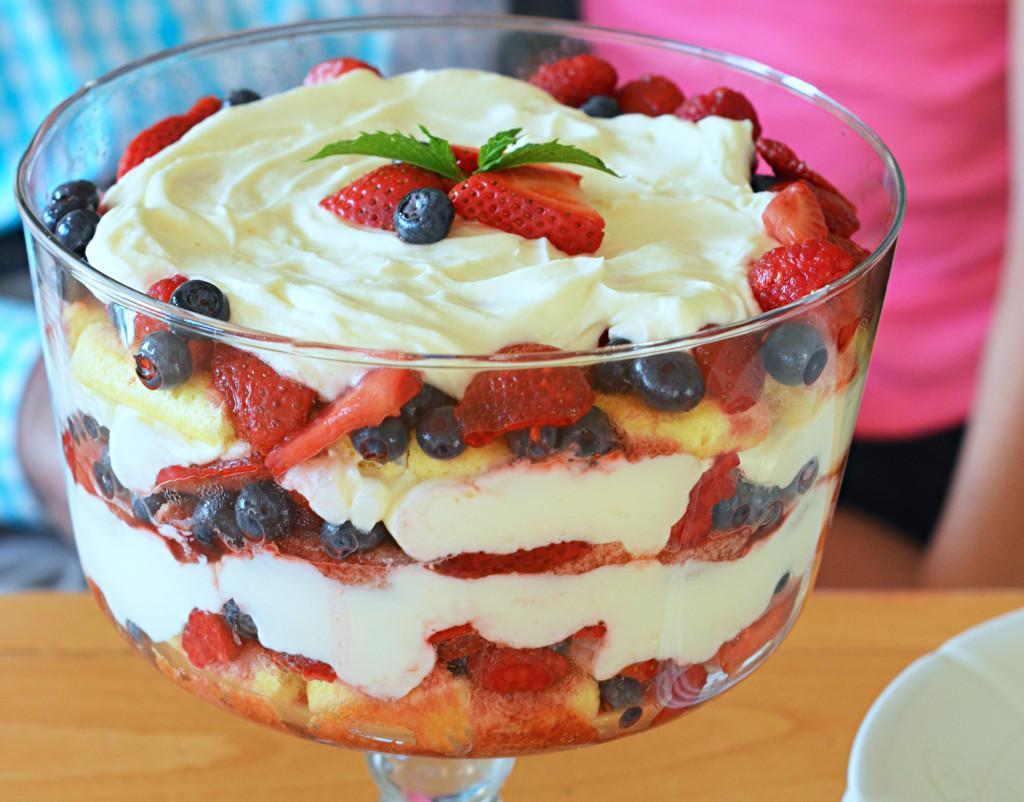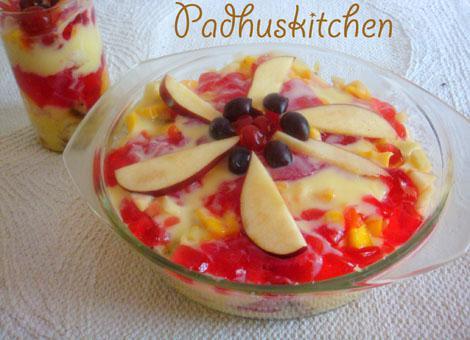The first image is the image on the left, the second image is the image on the right. Analyze the images presented: Is the assertion "The image to the right is in a cup instead of a bowl." valid? Answer yes or no. No. 